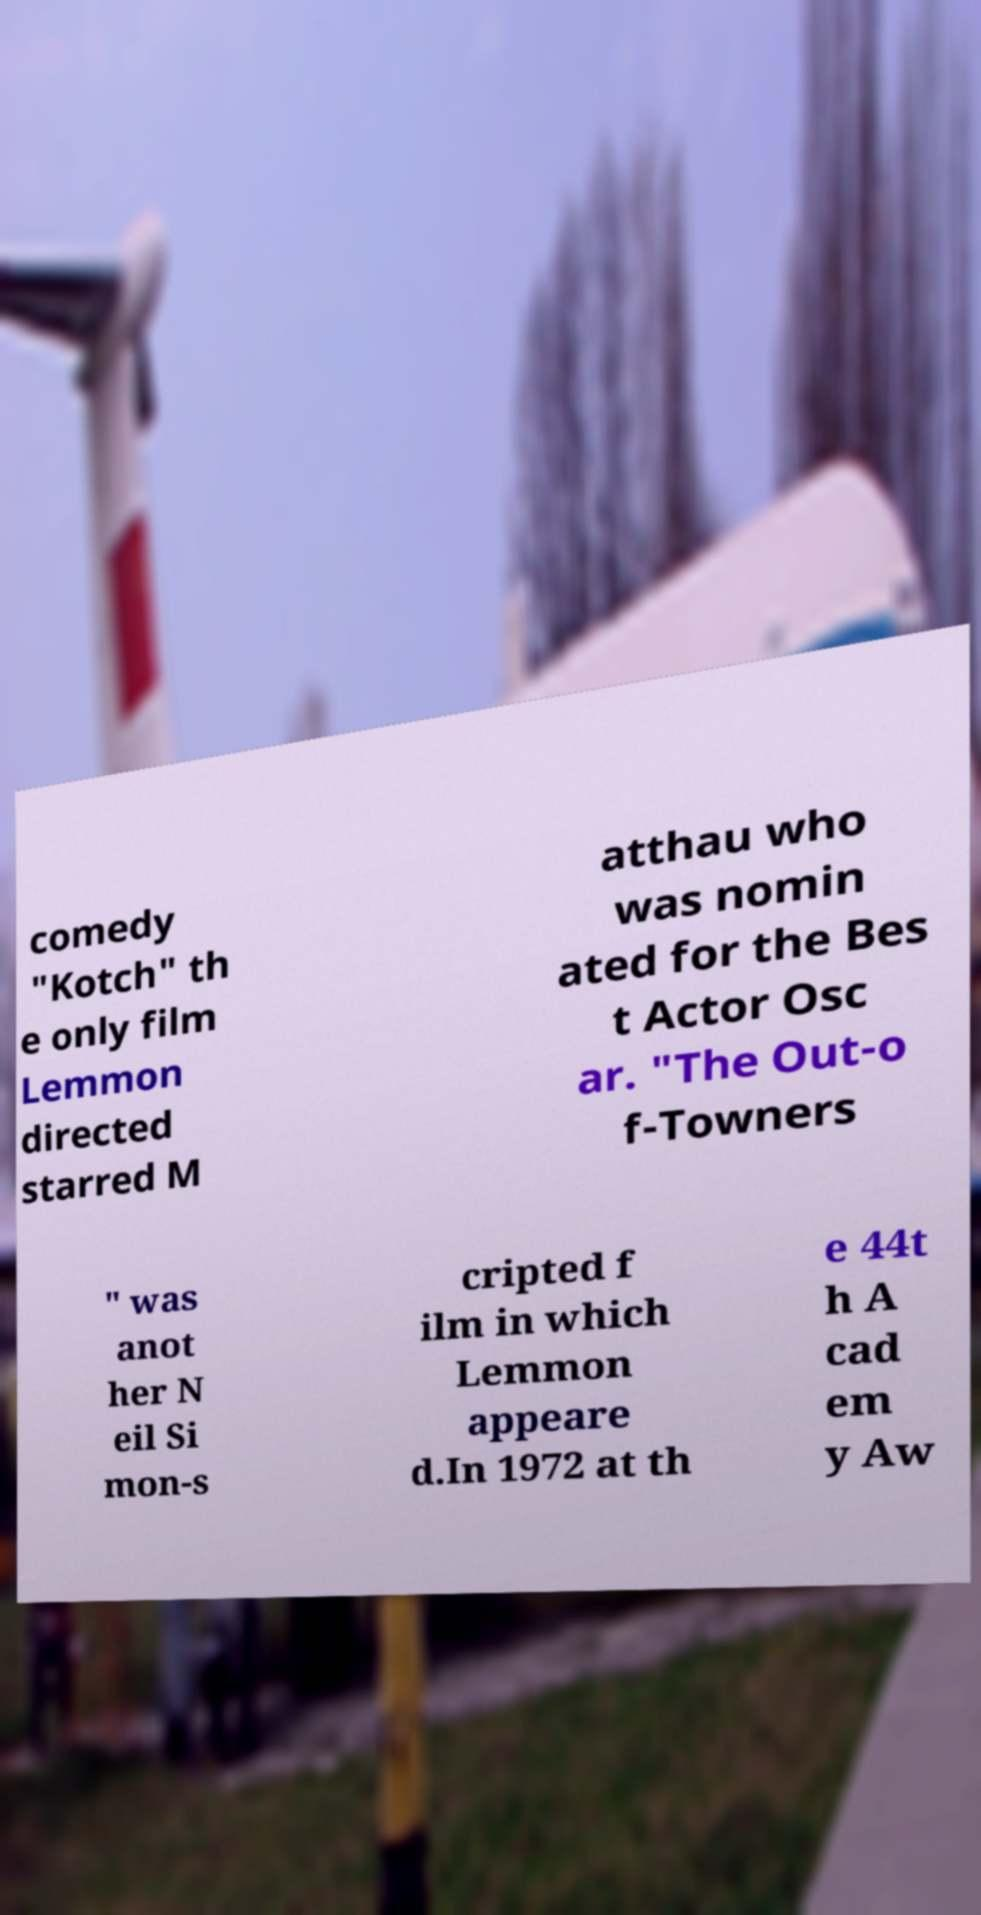Can you accurately transcribe the text from the provided image for me? comedy "Kotch" th e only film Lemmon directed starred M atthau who was nomin ated for the Bes t Actor Osc ar. "The Out-o f-Towners " was anot her N eil Si mon-s cripted f ilm in which Lemmon appeare d.In 1972 at th e 44t h A cad em y Aw 